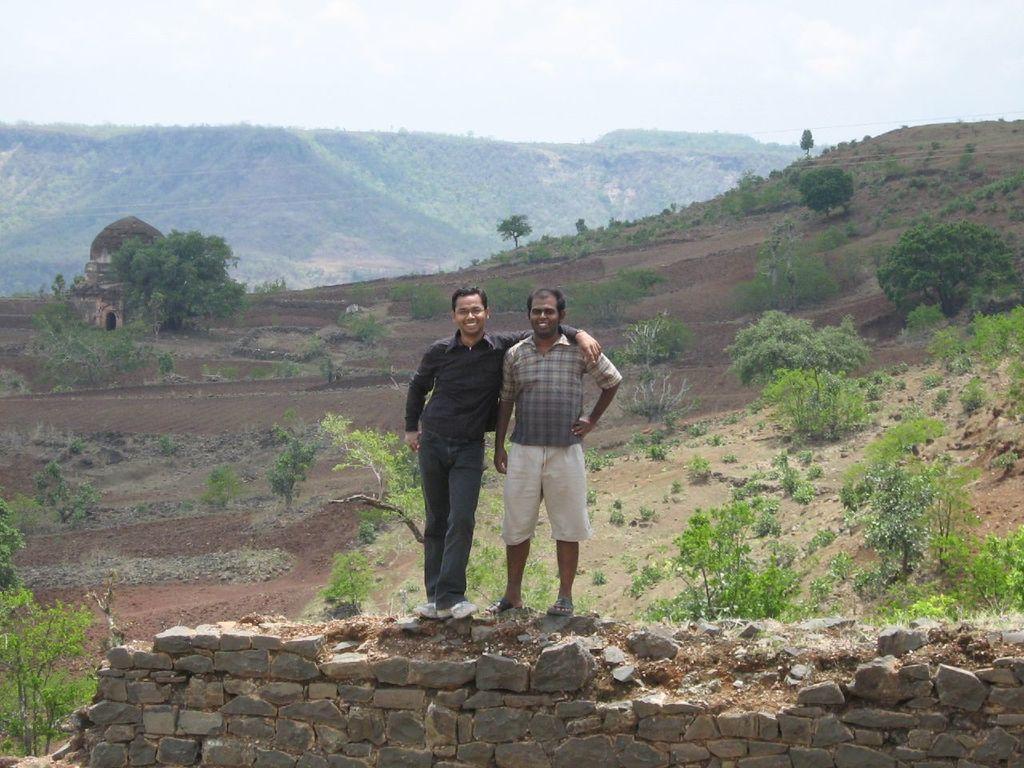In one or two sentences, can you explain what this image depicts? This picture is taken from outside of the city. In this image, in the middle, we can see two men are standing on the stones. On the right side, we can see some trees and plants. On the left side, we can also see a building, trees and plants. In the background, we can see some trees, buildings, rocks. At the top, we can see a sky, at the bottom, we can see a land with some stones. 